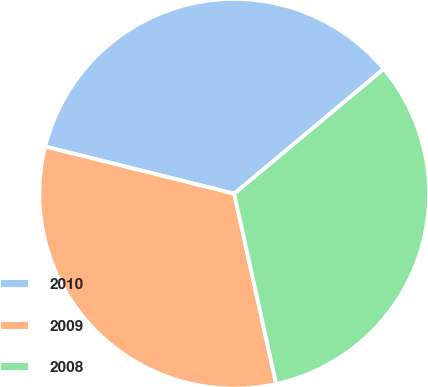Convert chart. <chart><loc_0><loc_0><loc_500><loc_500><pie_chart><fcel>2010<fcel>2009<fcel>2008<nl><fcel>35.04%<fcel>32.35%<fcel>32.61%<nl></chart> 